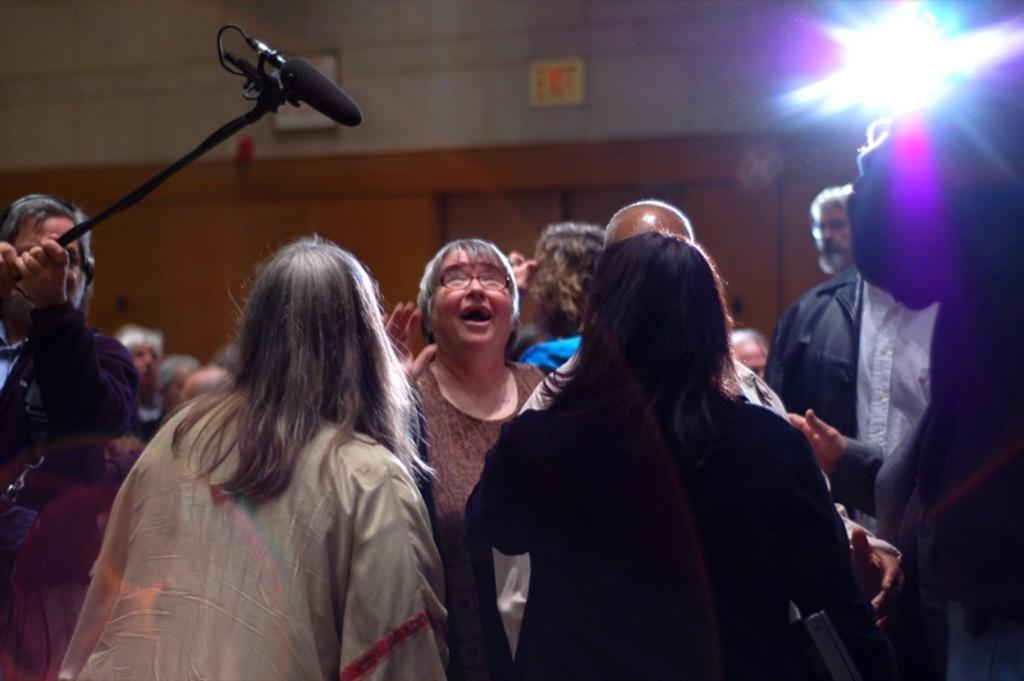What is happening in the image? There are people standing in the image, and a person is holding a microphone with a stand on the left side. Can you describe the background of the image? The background includes light and boards on a wall. What might be happening in the image based on the presence of the microphone? It is possible that someone is giving a speech or presentation, as the microphone is typically used for amplifying sound. What is the condition of the war in the image? There is no war present in the image; it features people standing and a person holding a microphone with a stand. Can you provide an example of the boards on the wall in the image? The boards on the wall in the image cannot be described in detail, as the image does not provide enough information to determine their specific appearance or purpose. 